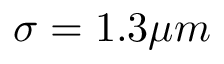<formula> <loc_0><loc_0><loc_500><loc_500>\sigma = 1 . 3 \mu m</formula> 